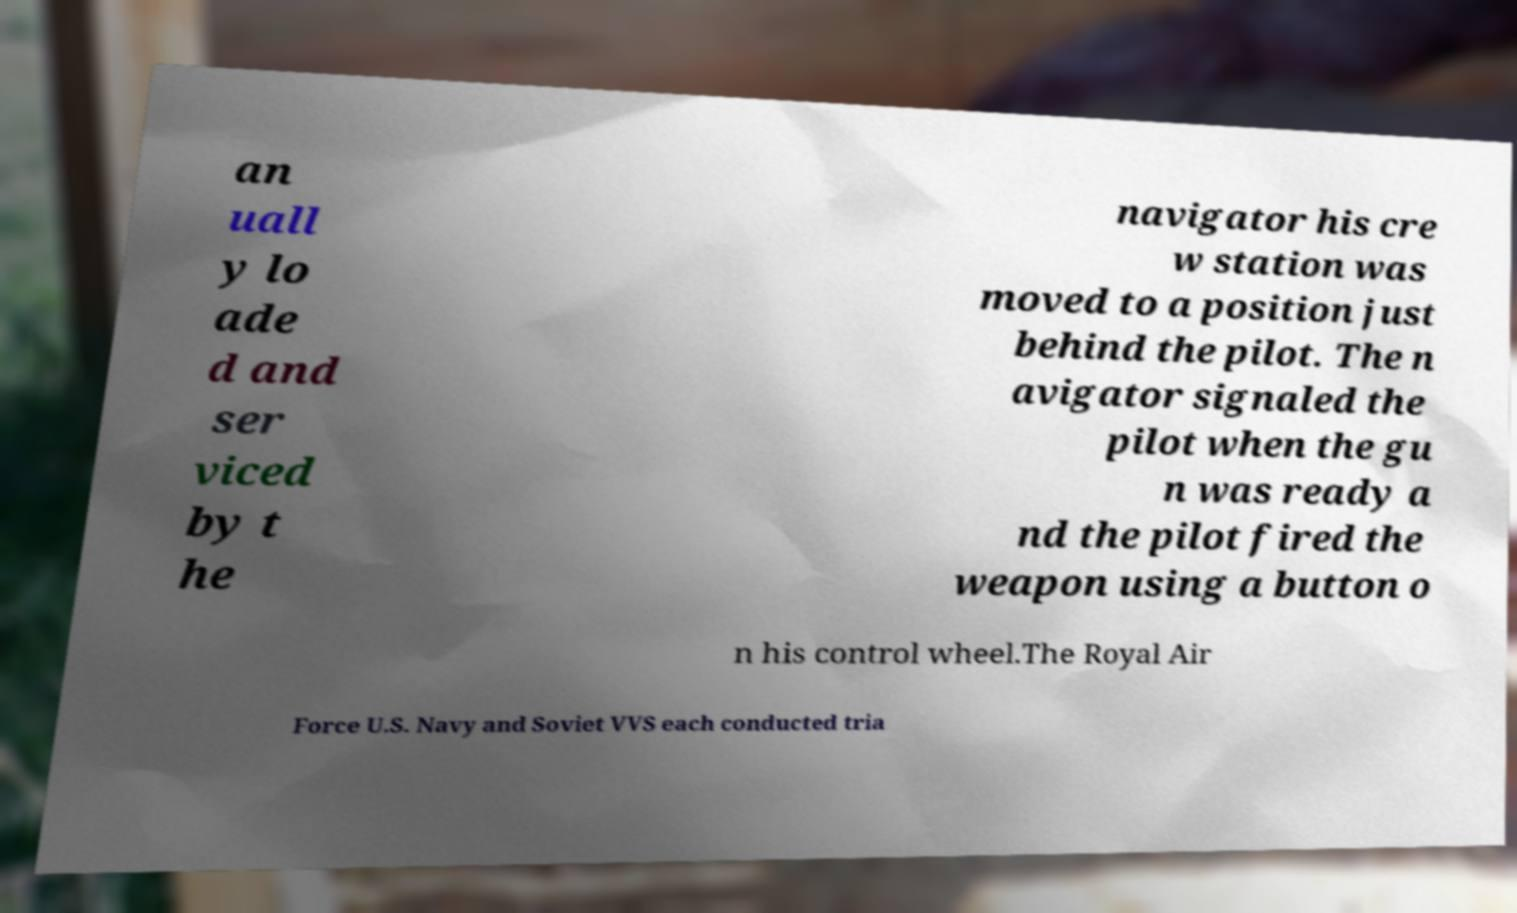Please identify and transcribe the text found in this image. an uall y lo ade d and ser viced by t he navigator his cre w station was moved to a position just behind the pilot. The n avigator signaled the pilot when the gu n was ready a nd the pilot fired the weapon using a button o n his control wheel.The Royal Air Force U.S. Navy and Soviet VVS each conducted tria 